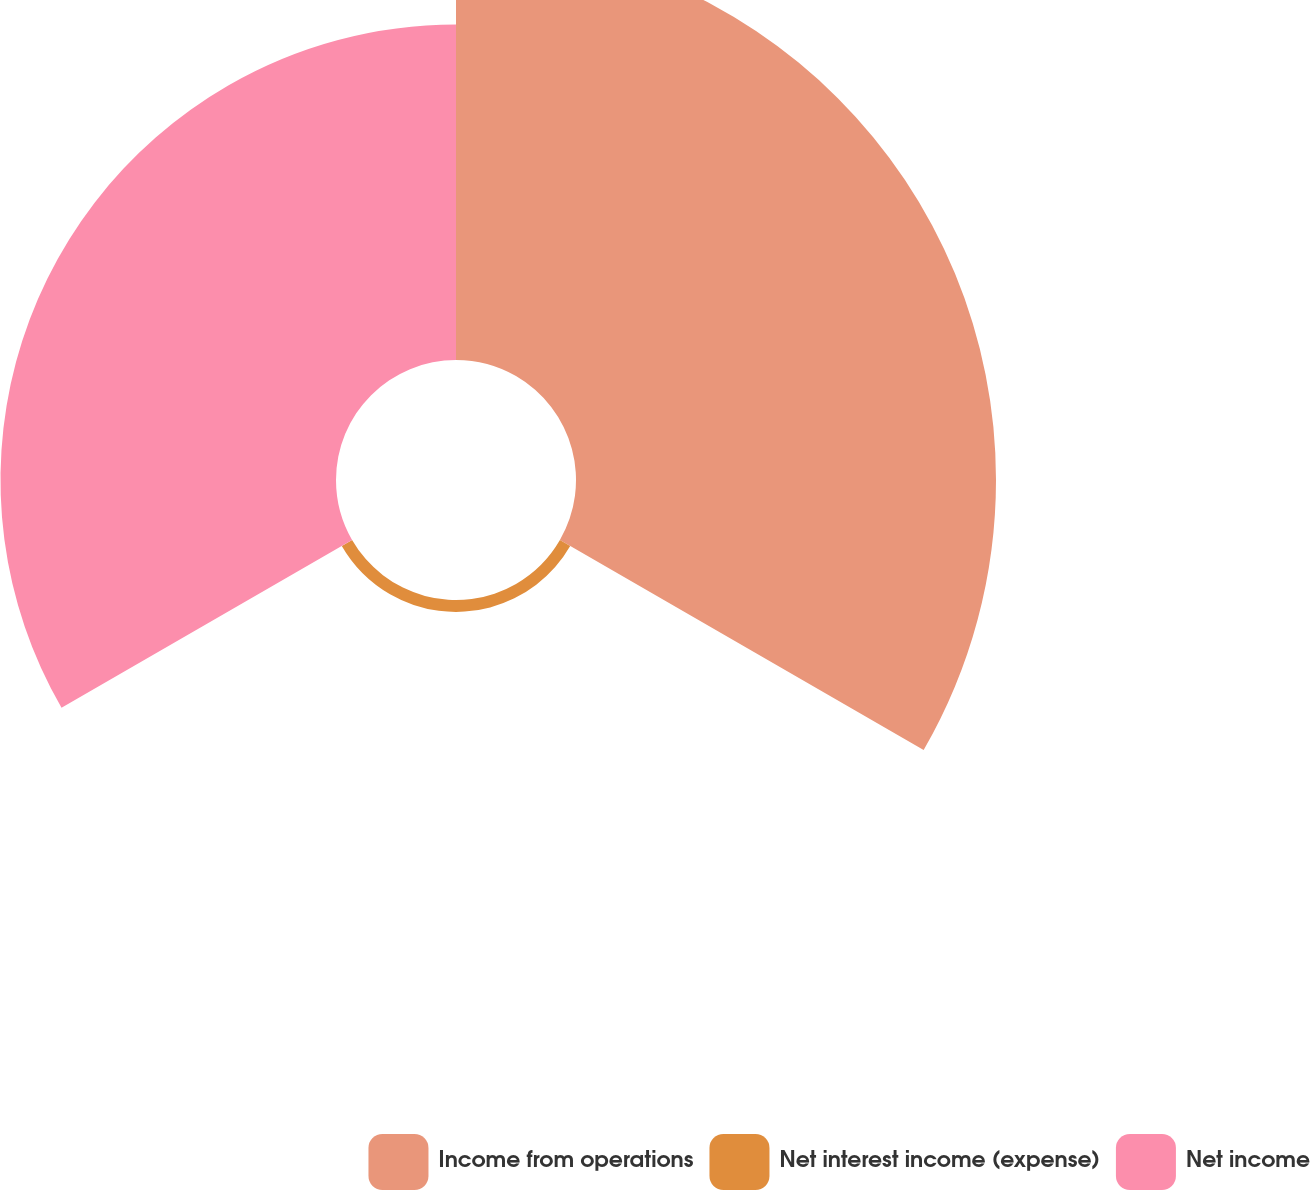<chart> <loc_0><loc_0><loc_500><loc_500><pie_chart><fcel>Income from operations<fcel>Net interest income (expense)<fcel>Net income<nl><fcel>54.73%<fcel>1.55%<fcel>43.72%<nl></chart> 